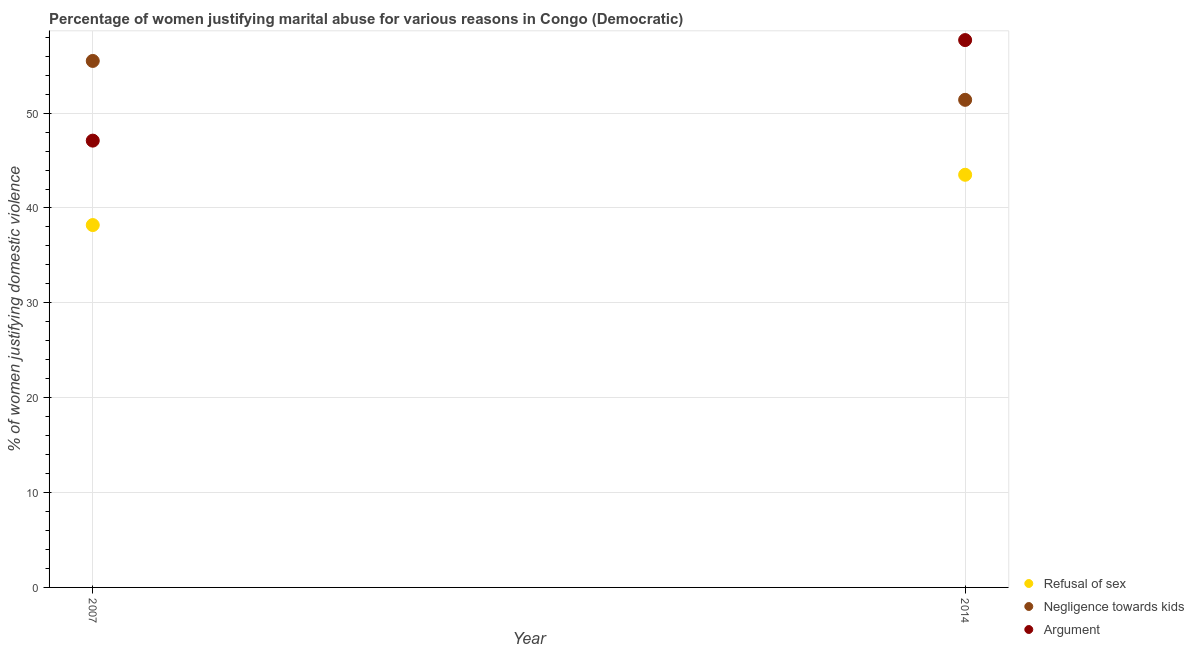What is the percentage of women justifying domestic violence due to negligence towards kids in 2014?
Give a very brief answer. 51.4. Across all years, what is the maximum percentage of women justifying domestic violence due to refusal of sex?
Offer a very short reply. 43.5. Across all years, what is the minimum percentage of women justifying domestic violence due to arguments?
Make the answer very short. 47.1. In which year was the percentage of women justifying domestic violence due to refusal of sex minimum?
Your answer should be compact. 2007. What is the total percentage of women justifying domestic violence due to refusal of sex in the graph?
Give a very brief answer. 81.7. What is the difference between the percentage of women justifying domestic violence due to arguments in 2007 and that in 2014?
Your answer should be compact. -10.6. What is the difference between the percentage of women justifying domestic violence due to arguments in 2007 and the percentage of women justifying domestic violence due to refusal of sex in 2014?
Your answer should be compact. 3.6. What is the average percentage of women justifying domestic violence due to negligence towards kids per year?
Your answer should be compact. 53.45. In the year 2014, what is the difference between the percentage of women justifying domestic violence due to refusal of sex and percentage of women justifying domestic violence due to arguments?
Give a very brief answer. -14.2. In how many years, is the percentage of women justifying domestic violence due to negligence towards kids greater than 34 %?
Your response must be concise. 2. What is the ratio of the percentage of women justifying domestic violence due to negligence towards kids in 2007 to that in 2014?
Your answer should be compact. 1.08. In how many years, is the percentage of women justifying domestic violence due to refusal of sex greater than the average percentage of women justifying domestic violence due to refusal of sex taken over all years?
Provide a short and direct response. 1. Is the percentage of women justifying domestic violence due to arguments strictly greater than the percentage of women justifying domestic violence due to refusal of sex over the years?
Provide a short and direct response. Yes. How many years are there in the graph?
Your response must be concise. 2. Are the values on the major ticks of Y-axis written in scientific E-notation?
Make the answer very short. No. Where does the legend appear in the graph?
Provide a succinct answer. Bottom right. What is the title of the graph?
Provide a short and direct response. Percentage of women justifying marital abuse for various reasons in Congo (Democratic). What is the label or title of the X-axis?
Offer a terse response. Year. What is the label or title of the Y-axis?
Your answer should be compact. % of women justifying domestic violence. What is the % of women justifying domestic violence in Refusal of sex in 2007?
Make the answer very short. 38.2. What is the % of women justifying domestic violence of Negligence towards kids in 2007?
Your answer should be very brief. 55.5. What is the % of women justifying domestic violence of Argument in 2007?
Your answer should be compact. 47.1. What is the % of women justifying domestic violence in Refusal of sex in 2014?
Your answer should be compact. 43.5. What is the % of women justifying domestic violence in Negligence towards kids in 2014?
Offer a terse response. 51.4. What is the % of women justifying domestic violence of Argument in 2014?
Give a very brief answer. 57.7. Across all years, what is the maximum % of women justifying domestic violence in Refusal of sex?
Give a very brief answer. 43.5. Across all years, what is the maximum % of women justifying domestic violence in Negligence towards kids?
Provide a short and direct response. 55.5. Across all years, what is the maximum % of women justifying domestic violence of Argument?
Keep it short and to the point. 57.7. Across all years, what is the minimum % of women justifying domestic violence in Refusal of sex?
Provide a short and direct response. 38.2. Across all years, what is the minimum % of women justifying domestic violence in Negligence towards kids?
Your response must be concise. 51.4. Across all years, what is the minimum % of women justifying domestic violence in Argument?
Make the answer very short. 47.1. What is the total % of women justifying domestic violence of Refusal of sex in the graph?
Your answer should be compact. 81.7. What is the total % of women justifying domestic violence of Negligence towards kids in the graph?
Your response must be concise. 106.9. What is the total % of women justifying domestic violence in Argument in the graph?
Provide a succinct answer. 104.8. What is the difference between the % of women justifying domestic violence of Refusal of sex in 2007 and that in 2014?
Keep it short and to the point. -5.3. What is the difference between the % of women justifying domestic violence of Refusal of sex in 2007 and the % of women justifying domestic violence of Argument in 2014?
Give a very brief answer. -19.5. What is the average % of women justifying domestic violence of Refusal of sex per year?
Provide a short and direct response. 40.85. What is the average % of women justifying domestic violence of Negligence towards kids per year?
Your answer should be compact. 53.45. What is the average % of women justifying domestic violence of Argument per year?
Provide a short and direct response. 52.4. In the year 2007, what is the difference between the % of women justifying domestic violence of Refusal of sex and % of women justifying domestic violence of Negligence towards kids?
Provide a short and direct response. -17.3. In the year 2007, what is the difference between the % of women justifying domestic violence in Refusal of sex and % of women justifying domestic violence in Argument?
Keep it short and to the point. -8.9. In the year 2007, what is the difference between the % of women justifying domestic violence of Negligence towards kids and % of women justifying domestic violence of Argument?
Your answer should be very brief. 8.4. What is the ratio of the % of women justifying domestic violence in Refusal of sex in 2007 to that in 2014?
Offer a very short reply. 0.88. What is the ratio of the % of women justifying domestic violence of Negligence towards kids in 2007 to that in 2014?
Ensure brevity in your answer.  1.08. What is the ratio of the % of women justifying domestic violence of Argument in 2007 to that in 2014?
Your answer should be compact. 0.82. What is the difference between the highest and the second highest % of women justifying domestic violence in Argument?
Offer a terse response. 10.6. What is the difference between the highest and the lowest % of women justifying domestic violence of Negligence towards kids?
Your response must be concise. 4.1. 